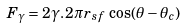<formula> <loc_0><loc_0><loc_500><loc_500>F _ { \gamma } = 2 \gamma . \, 2 \pi r _ { s f } \, \cos ( \theta - \theta _ { c } )</formula> 